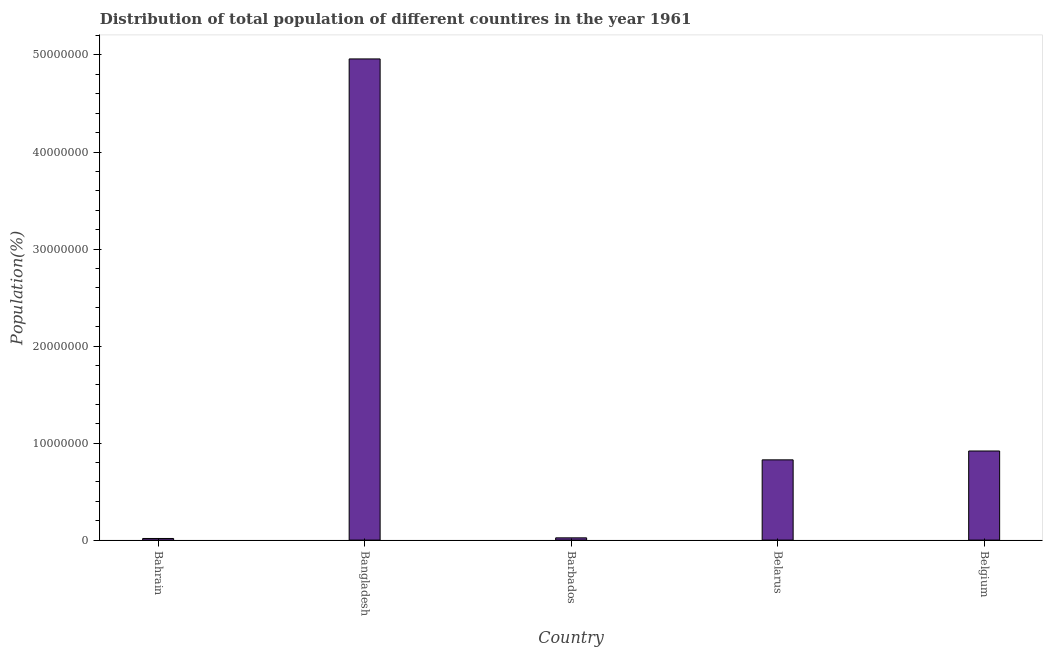What is the title of the graph?
Make the answer very short. Distribution of total population of different countires in the year 1961. What is the label or title of the X-axis?
Give a very brief answer. Country. What is the label or title of the Y-axis?
Provide a short and direct response. Population(%). What is the population in Belarus?
Keep it short and to the point. 8.27e+06. Across all countries, what is the maximum population?
Your response must be concise. 4.96e+07. Across all countries, what is the minimum population?
Provide a succinct answer. 1.68e+05. In which country was the population minimum?
Provide a succinct answer. Bahrain. What is the sum of the population?
Keep it short and to the point. 6.74e+07. What is the difference between the population in Bahrain and Barbados?
Offer a terse response. -6.38e+04. What is the average population per country?
Give a very brief answer. 1.35e+07. What is the median population?
Keep it short and to the point. 8.27e+06. What is the ratio of the population in Barbados to that in Belarus?
Keep it short and to the point. 0.03. What is the difference between the highest and the second highest population?
Provide a succinct answer. 4.04e+07. What is the difference between the highest and the lowest population?
Offer a very short reply. 4.94e+07. How many bars are there?
Offer a very short reply. 5. How many countries are there in the graph?
Your answer should be very brief. 5. Are the values on the major ticks of Y-axis written in scientific E-notation?
Provide a succinct answer. No. What is the Population(%) in Bahrain?
Keep it short and to the point. 1.68e+05. What is the Population(%) in Bangladesh?
Ensure brevity in your answer.  4.96e+07. What is the Population(%) of Barbados?
Keep it short and to the point. 2.32e+05. What is the Population(%) in Belarus?
Your answer should be compact. 8.27e+06. What is the Population(%) in Belgium?
Give a very brief answer. 9.18e+06. What is the difference between the Population(%) in Bahrain and Bangladesh?
Give a very brief answer. -4.94e+07. What is the difference between the Population(%) in Bahrain and Barbados?
Provide a short and direct response. -6.38e+04. What is the difference between the Population(%) in Bahrain and Belarus?
Your response must be concise. -8.10e+06. What is the difference between the Population(%) in Bahrain and Belgium?
Offer a terse response. -9.02e+06. What is the difference between the Population(%) in Bangladesh and Barbados?
Give a very brief answer. 4.94e+07. What is the difference between the Population(%) in Bangladesh and Belarus?
Your response must be concise. 4.13e+07. What is the difference between the Population(%) in Bangladesh and Belgium?
Your answer should be very brief. 4.04e+07. What is the difference between the Population(%) in Barbados and Belarus?
Make the answer very short. -8.04e+06. What is the difference between the Population(%) in Barbados and Belgium?
Give a very brief answer. -8.95e+06. What is the difference between the Population(%) in Belarus and Belgium?
Keep it short and to the point. -9.13e+05. What is the ratio of the Population(%) in Bahrain to that in Bangladesh?
Offer a very short reply. 0. What is the ratio of the Population(%) in Bahrain to that in Barbados?
Provide a succinct answer. 0.72. What is the ratio of the Population(%) in Bahrain to that in Belarus?
Your response must be concise. 0.02. What is the ratio of the Population(%) in Bahrain to that in Belgium?
Your answer should be compact. 0.02. What is the ratio of the Population(%) in Bangladesh to that in Barbados?
Offer a terse response. 214.07. What is the ratio of the Population(%) in Bangladesh to that in Belarus?
Provide a short and direct response. 6. What is the ratio of the Population(%) in Barbados to that in Belarus?
Keep it short and to the point. 0.03. What is the ratio of the Population(%) in Barbados to that in Belgium?
Provide a short and direct response. 0.03. What is the ratio of the Population(%) in Belarus to that in Belgium?
Your answer should be compact. 0.9. 